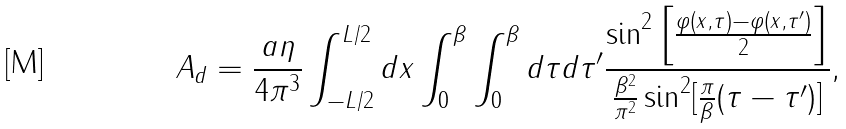Convert formula to latex. <formula><loc_0><loc_0><loc_500><loc_500>A _ { d } = \frac { a \eta } { 4 \pi ^ { 3 } } \int _ { - L / 2 } ^ { L / 2 } d x \int _ { 0 } ^ { \beta } \int _ { 0 } ^ { \beta } d \tau d \tau ^ { \prime } \frac { \sin ^ { 2 } \left [ \frac { \varphi ( x , \tau ) - \varphi ( x , \tau ^ { \prime } ) } { 2 } \right ] } { \frac { \beta ^ { 2 } } { \pi ^ { 2 } } \sin ^ { 2 } [ \frac { \pi } { \beta } ( \tau - \tau ^ { \prime } ) ] } ,</formula> 